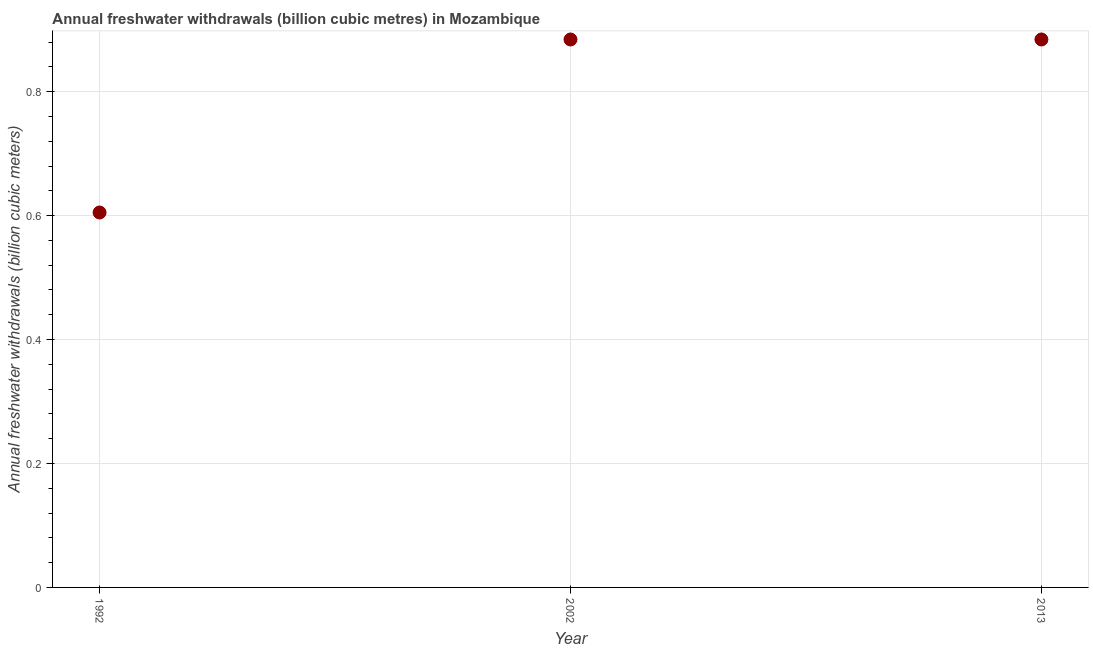What is the annual freshwater withdrawals in 2013?
Provide a short and direct response. 0.88. Across all years, what is the maximum annual freshwater withdrawals?
Your response must be concise. 0.88. Across all years, what is the minimum annual freshwater withdrawals?
Your answer should be very brief. 0.6. In which year was the annual freshwater withdrawals minimum?
Your answer should be very brief. 1992. What is the sum of the annual freshwater withdrawals?
Your answer should be very brief. 2.37. What is the difference between the annual freshwater withdrawals in 1992 and 2002?
Provide a short and direct response. -0.28. What is the average annual freshwater withdrawals per year?
Provide a short and direct response. 0.79. What is the median annual freshwater withdrawals?
Offer a terse response. 0.88. In how many years, is the annual freshwater withdrawals greater than 0.24000000000000002 billion cubic meters?
Your response must be concise. 3. Do a majority of the years between 1992 and 2013 (inclusive) have annual freshwater withdrawals greater than 0.52 billion cubic meters?
Provide a short and direct response. Yes. What is the ratio of the annual freshwater withdrawals in 1992 to that in 2002?
Your answer should be very brief. 0.68. Is the sum of the annual freshwater withdrawals in 2002 and 2013 greater than the maximum annual freshwater withdrawals across all years?
Offer a terse response. Yes. What is the difference between the highest and the lowest annual freshwater withdrawals?
Your response must be concise. 0.28. In how many years, is the annual freshwater withdrawals greater than the average annual freshwater withdrawals taken over all years?
Your answer should be compact. 2. Does the annual freshwater withdrawals monotonically increase over the years?
Offer a terse response. No. How many dotlines are there?
Offer a very short reply. 1. What is the difference between two consecutive major ticks on the Y-axis?
Provide a succinct answer. 0.2. Does the graph contain any zero values?
Keep it short and to the point. No. What is the title of the graph?
Offer a terse response. Annual freshwater withdrawals (billion cubic metres) in Mozambique. What is the label or title of the Y-axis?
Give a very brief answer. Annual freshwater withdrawals (billion cubic meters). What is the Annual freshwater withdrawals (billion cubic meters) in 1992?
Give a very brief answer. 0.6. What is the Annual freshwater withdrawals (billion cubic meters) in 2002?
Your answer should be compact. 0.88. What is the Annual freshwater withdrawals (billion cubic meters) in 2013?
Keep it short and to the point. 0.88. What is the difference between the Annual freshwater withdrawals (billion cubic meters) in 1992 and 2002?
Provide a short and direct response. -0.28. What is the difference between the Annual freshwater withdrawals (billion cubic meters) in 1992 and 2013?
Offer a very short reply. -0.28. What is the ratio of the Annual freshwater withdrawals (billion cubic meters) in 1992 to that in 2002?
Make the answer very short. 0.68. What is the ratio of the Annual freshwater withdrawals (billion cubic meters) in 1992 to that in 2013?
Provide a short and direct response. 0.68. 